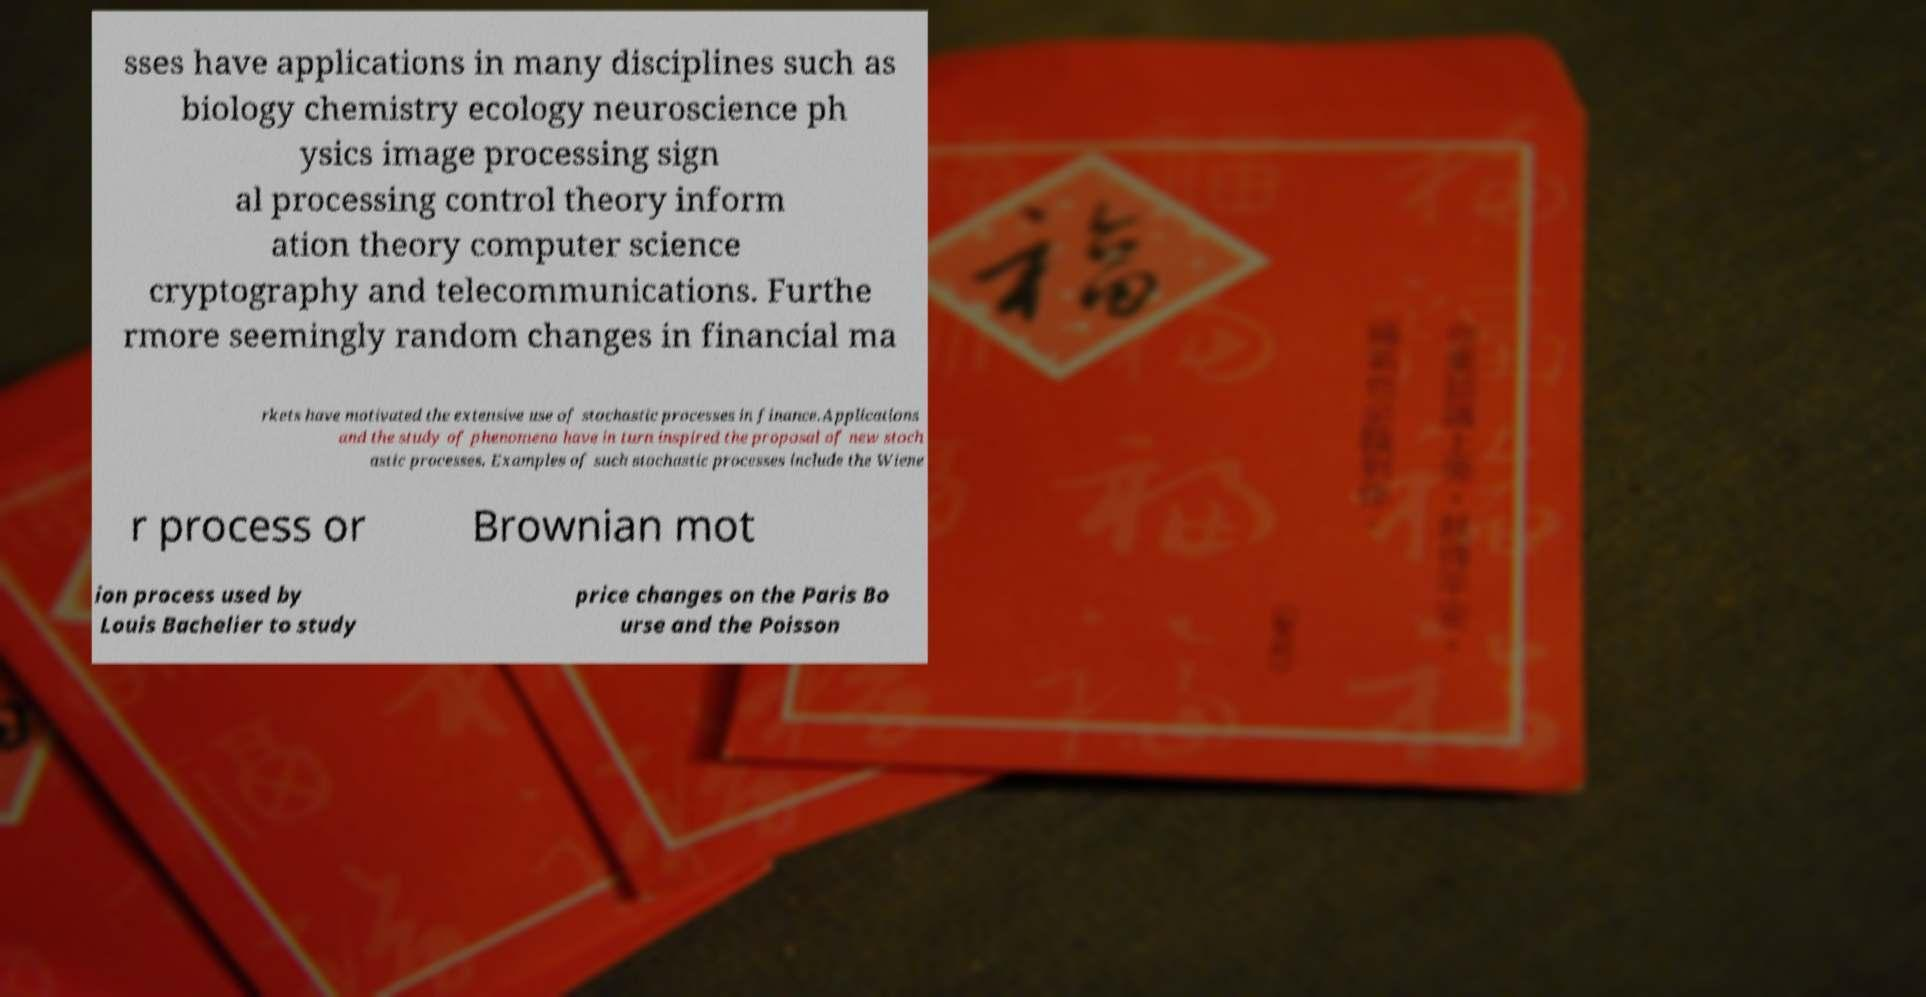Please read and relay the text visible in this image. What does it say? sses have applications in many disciplines such as biology chemistry ecology neuroscience ph ysics image processing sign al processing control theory inform ation theory computer science cryptography and telecommunications. Furthe rmore seemingly random changes in financial ma rkets have motivated the extensive use of stochastic processes in finance.Applications and the study of phenomena have in turn inspired the proposal of new stoch astic processes. Examples of such stochastic processes include the Wiene r process or Brownian mot ion process used by Louis Bachelier to study price changes on the Paris Bo urse and the Poisson 